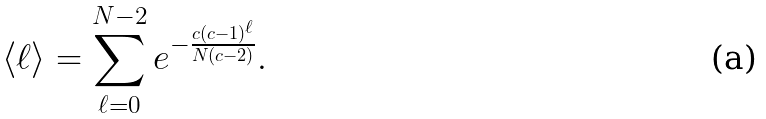<formula> <loc_0><loc_0><loc_500><loc_500>\langle \ell \rangle = \sum _ { \ell = 0 } ^ { N - 2 } e ^ { - \frac { c ( c - 1 ) ^ { \ell } } { N ( c - 2 ) } } .</formula> 